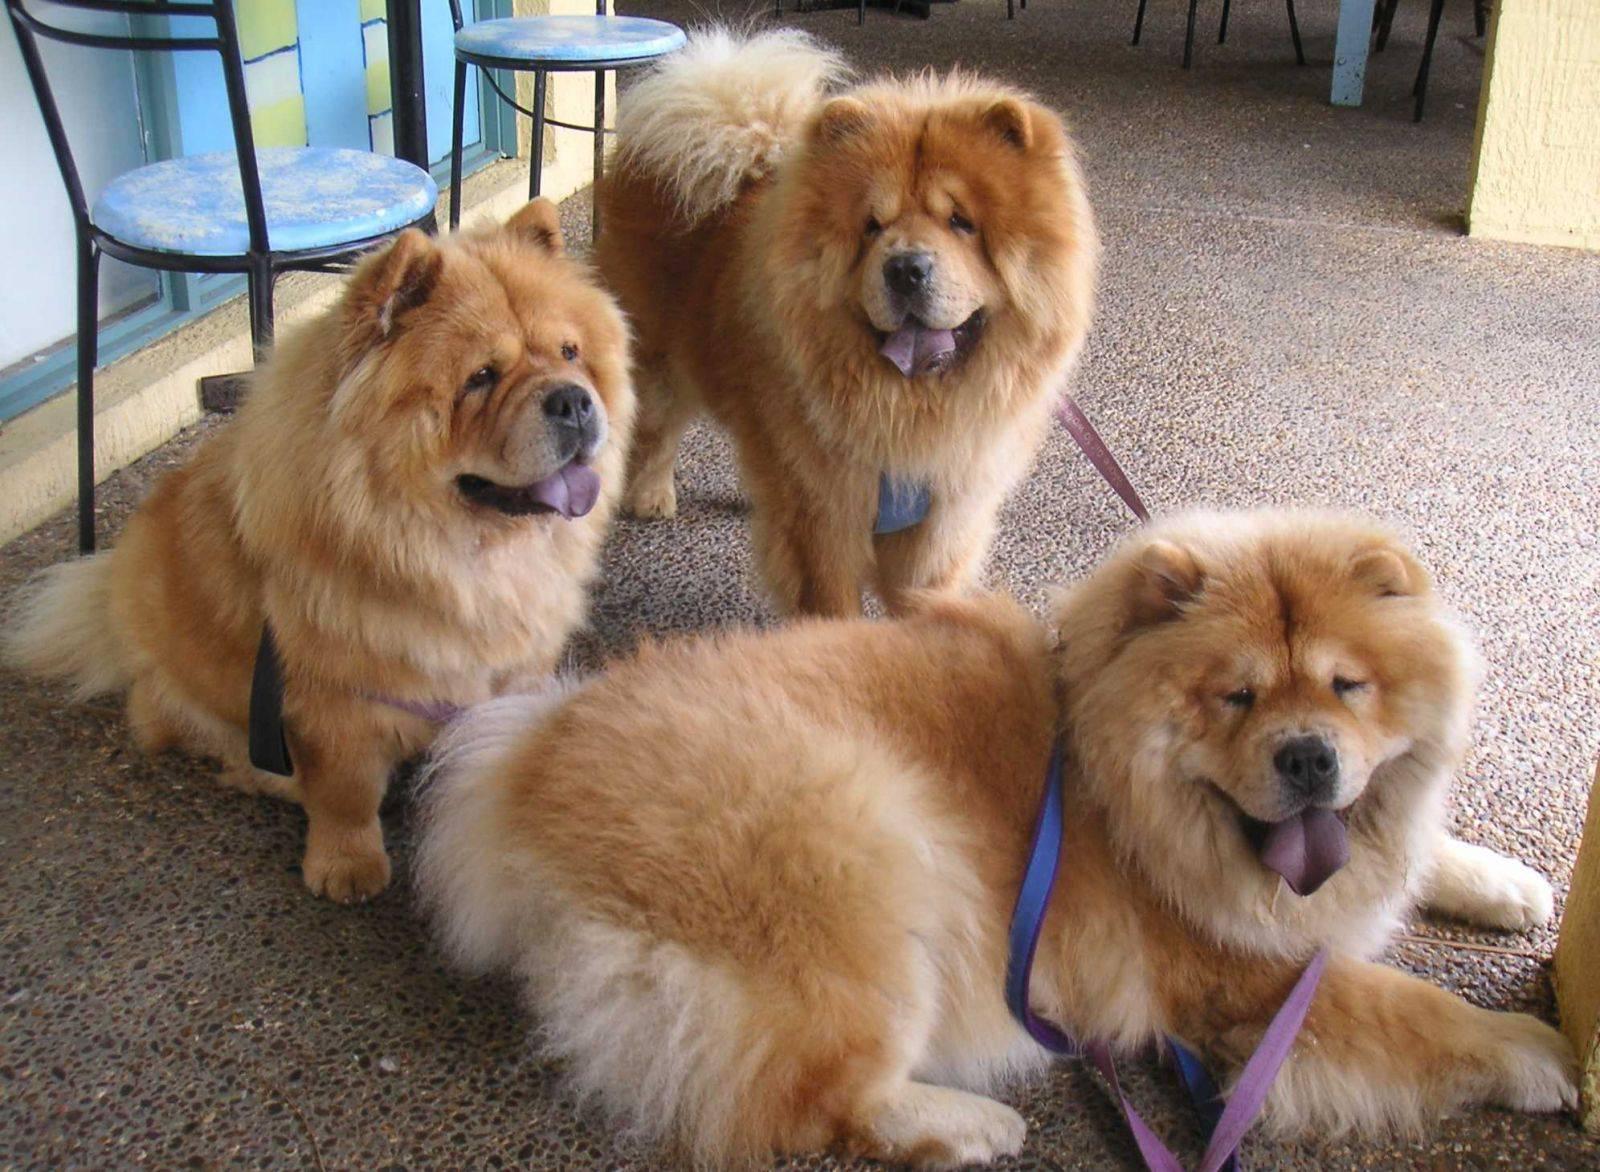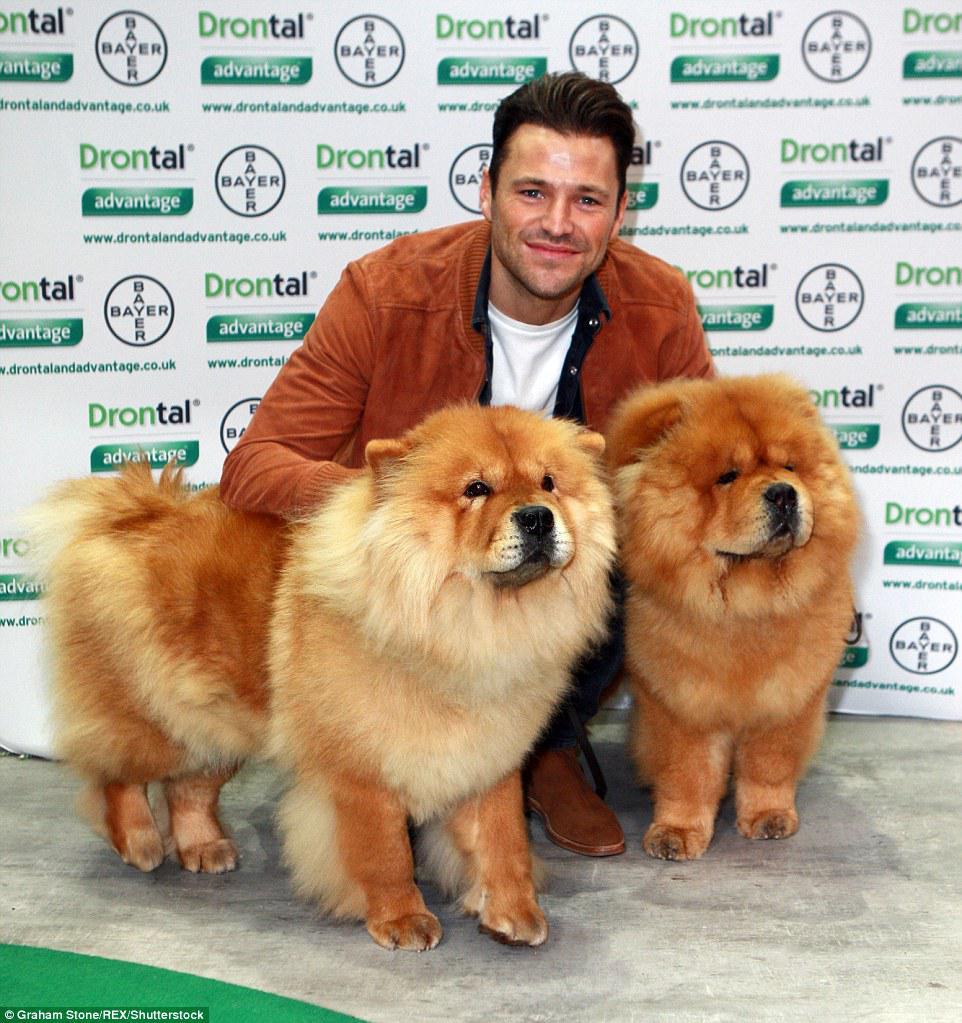The first image is the image on the left, the second image is the image on the right. Considering the images on both sides, is "There are at least four dogs." valid? Answer yes or no. Yes. 